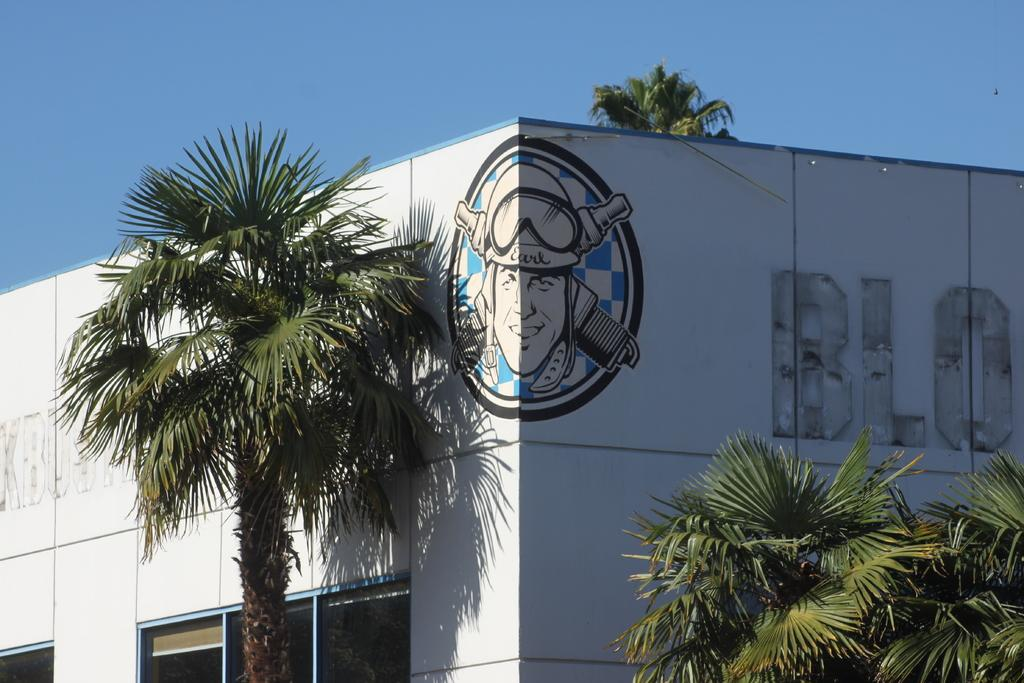What type of vegetation is visible in the image? There are trees in the image. What type of structure is present in the image? There is a building in the image. What is written or displayed on the building? There is a logo with some text on the building. How many hands can be seen holding the trees in the image? There are no hands visible holding the trees in the image. What type of guide is present in the image to help navigate the area? There is no guide present in the image; it only features trees and a building. 